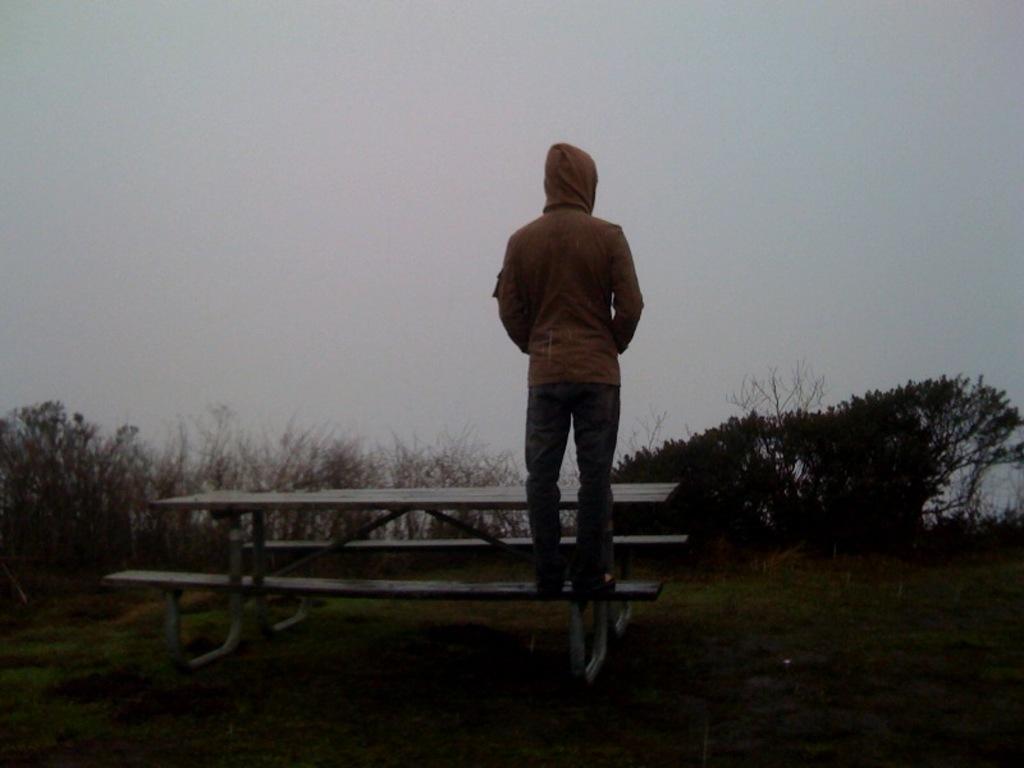How would you summarize this image in a sentence or two? In this image we can see a man standing on a bench. We can also see grass, a group of trees and the sky. 